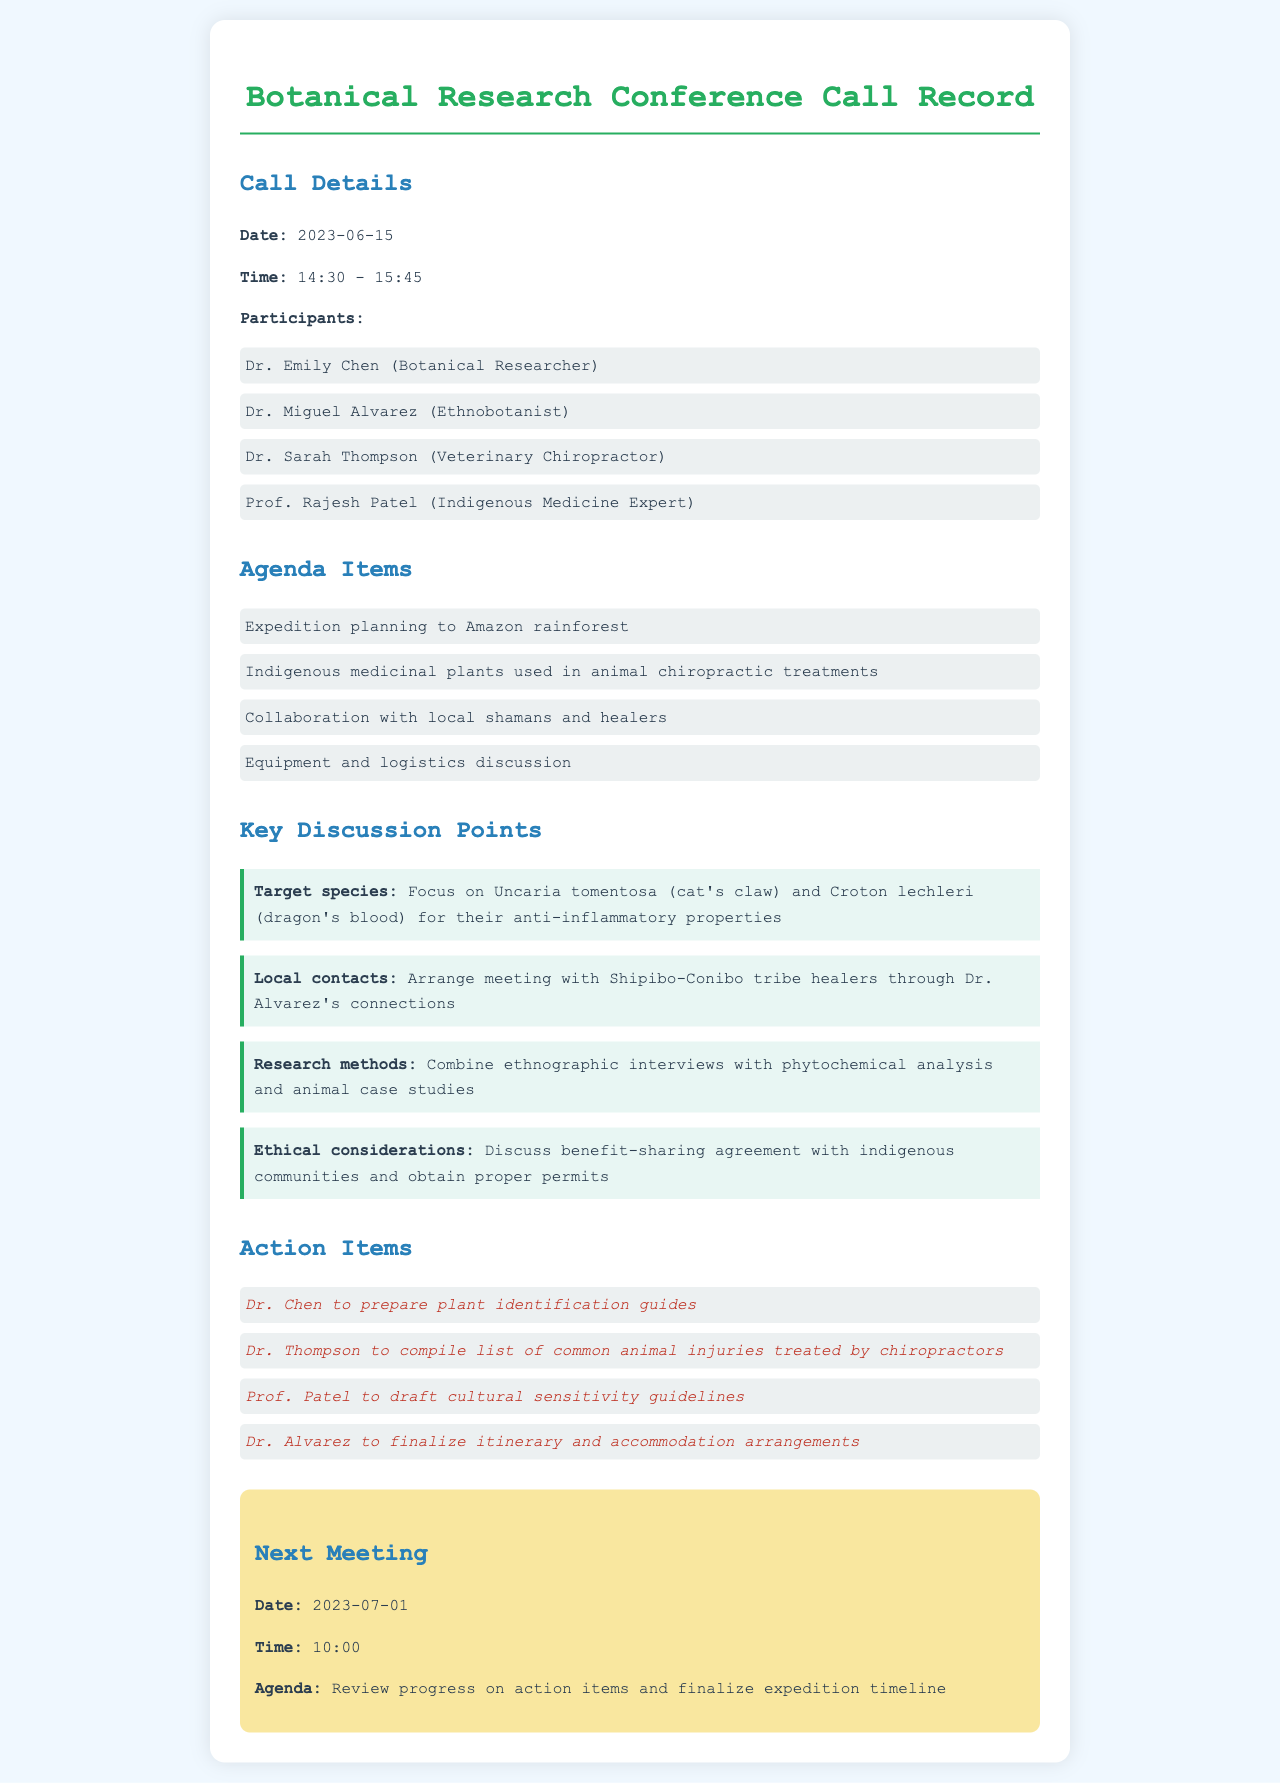What is the date of the conference call? The date of the conference call is listed in the "Call Details" section.
Answer: 2023-06-15 Who is the Ethnobotanist in the call? The participants are listed in the "Participants" section, specifying their roles.
Answer: Dr. Miguel Alvarez What are the target species discussed? The key discussion points include specific plants and their properties.
Answer: Uncaria tomentosa and Croton lechleri What is one action item for Dr. Thompson? The action items section specifies the responsibilities assigned to each participant.
Answer: Compile list of common animal injuries treated by chiropractors When is the next meeting scheduled? The next meeting date is found in the "Next Meeting" section of the document.
Answer: 2023-07-01 What is a method proposed for research? Proposed research methods are highlighted in the key discussion points.
Answer: Combine ethnographic interviews with phytochemical analysis and animal case studies What ethical consideration was discussed? The ethical considerations involve agreements related to indigenous communities.
Answer: Benefit-sharing agreement How long did the conference call last? The duration of the call is indicated in the "Call Details" section by the time range.
Answer: 1 hour and 15 minutes 